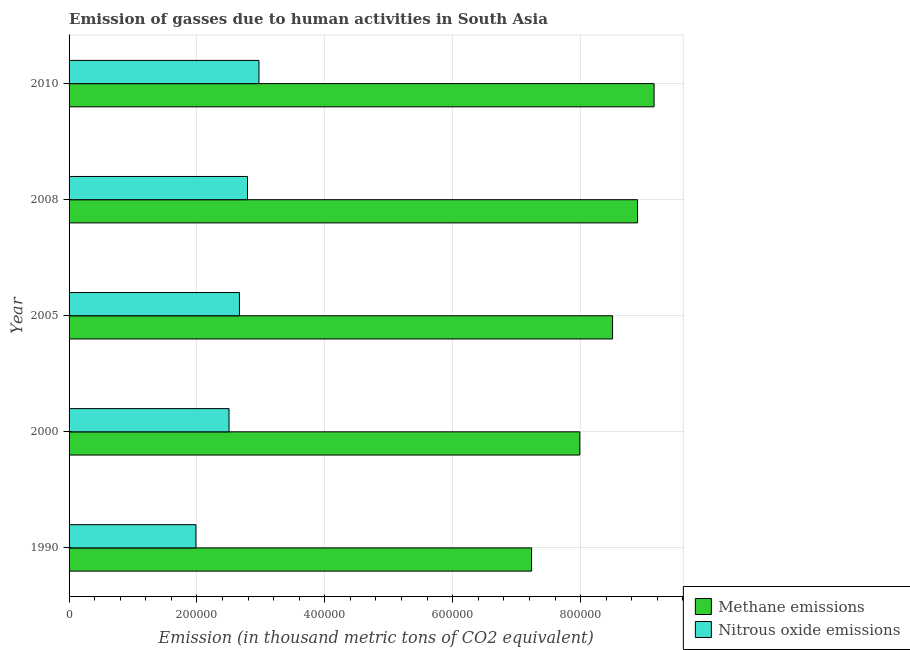How many different coloured bars are there?
Make the answer very short. 2. Are the number of bars on each tick of the Y-axis equal?
Make the answer very short. Yes. What is the amount of methane emissions in 2005?
Make the answer very short. 8.50e+05. Across all years, what is the maximum amount of methane emissions?
Make the answer very short. 9.15e+05. Across all years, what is the minimum amount of methane emissions?
Keep it short and to the point. 7.23e+05. In which year was the amount of nitrous oxide emissions maximum?
Your response must be concise. 2010. What is the total amount of nitrous oxide emissions in the graph?
Your answer should be very brief. 1.29e+06. What is the difference between the amount of methane emissions in 2008 and that in 2010?
Provide a succinct answer. -2.59e+04. What is the difference between the amount of methane emissions in 2005 and the amount of nitrous oxide emissions in 2010?
Your answer should be compact. 5.53e+05. What is the average amount of nitrous oxide emissions per year?
Your answer should be very brief. 2.58e+05. In the year 2008, what is the difference between the amount of nitrous oxide emissions and amount of methane emissions?
Ensure brevity in your answer.  -6.10e+05. In how many years, is the amount of methane emissions greater than 80000 thousand metric tons?
Your answer should be compact. 5. What is the ratio of the amount of methane emissions in 2000 to that in 2010?
Offer a very short reply. 0.87. Is the amount of methane emissions in 2005 less than that in 2008?
Offer a very short reply. Yes. Is the difference between the amount of methane emissions in 1990 and 2000 greater than the difference between the amount of nitrous oxide emissions in 1990 and 2000?
Keep it short and to the point. No. What is the difference between the highest and the second highest amount of methane emissions?
Provide a short and direct response. 2.59e+04. What is the difference between the highest and the lowest amount of methane emissions?
Provide a short and direct response. 1.92e+05. In how many years, is the amount of methane emissions greater than the average amount of methane emissions taken over all years?
Your answer should be very brief. 3. What does the 1st bar from the top in 1990 represents?
Provide a short and direct response. Nitrous oxide emissions. What does the 1st bar from the bottom in 1990 represents?
Provide a succinct answer. Methane emissions. How many bars are there?
Give a very brief answer. 10. How many years are there in the graph?
Provide a succinct answer. 5. What is the difference between two consecutive major ticks on the X-axis?
Offer a terse response. 2.00e+05. Are the values on the major ticks of X-axis written in scientific E-notation?
Keep it short and to the point. No. Where does the legend appear in the graph?
Keep it short and to the point. Bottom right. How many legend labels are there?
Provide a short and direct response. 2. What is the title of the graph?
Offer a terse response. Emission of gasses due to human activities in South Asia. What is the label or title of the X-axis?
Your response must be concise. Emission (in thousand metric tons of CO2 equivalent). What is the label or title of the Y-axis?
Your answer should be compact. Year. What is the Emission (in thousand metric tons of CO2 equivalent) in Methane emissions in 1990?
Provide a short and direct response. 7.23e+05. What is the Emission (in thousand metric tons of CO2 equivalent) in Nitrous oxide emissions in 1990?
Ensure brevity in your answer.  1.98e+05. What is the Emission (in thousand metric tons of CO2 equivalent) in Methane emissions in 2000?
Your response must be concise. 7.99e+05. What is the Emission (in thousand metric tons of CO2 equivalent) in Nitrous oxide emissions in 2000?
Offer a terse response. 2.50e+05. What is the Emission (in thousand metric tons of CO2 equivalent) in Methane emissions in 2005?
Ensure brevity in your answer.  8.50e+05. What is the Emission (in thousand metric tons of CO2 equivalent) of Nitrous oxide emissions in 2005?
Your response must be concise. 2.66e+05. What is the Emission (in thousand metric tons of CO2 equivalent) of Methane emissions in 2008?
Ensure brevity in your answer.  8.89e+05. What is the Emission (in thousand metric tons of CO2 equivalent) of Nitrous oxide emissions in 2008?
Your answer should be compact. 2.79e+05. What is the Emission (in thousand metric tons of CO2 equivalent) in Methane emissions in 2010?
Your answer should be very brief. 9.15e+05. What is the Emission (in thousand metric tons of CO2 equivalent) of Nitrous oxide emissions in 2010?
Provide a short and direct response. 2.97e+05. Across all years, what is the maximum Emission (in thousand metric tons of CO2 equivalent) in Methane emissions?
Make the answer very short. 9.15e+05. Across all years, what is the maximum Emission (in thousand metric tons of CO2 equivalent) of Nitrous oxide emissions?
Make the answer very short. 2.97e+05. Across all years, what is the minimum Emission (in thousand metric tons of CO2 equivalent) of Methane emissions?
Offer a very short reply. 7.23e+05. Across all years, what is the minimum Emission (in thousand metric tons of CO2 equivalent) in Nitrous oxide emissions?
Offer a terse response. 1.98e+05. What is the total Emission (in thousand metric tons of CO2 equivalent) of Methane emissions in the graph?
Provide a succinct answer. 4.18e+06. What is the total Emission (in thousand metric tons of CO2 equivalent) of Nitrous oxide emissions in the graph?
Give a very brief answer. 1.29e+06. What is the difference between the Emission (in thousand metric tons of CO2 equivalent) in Methane emissions in 1990 and that in 2000?
Offer a very short reply. -7.54e+04. What is the difference between the Emission (in thousand metric tons of CO2 equivalent) in Nitrous oxide emissions in 1990 and that in 2000?
Make the answer very short. -5.17e+04. What is the difference between the Emission (in thousand metric tons of CO2 equivalent) in Methane emissions in 1990 and that in 2005?
Make the answer very short. -1.27e+05. What is the difference between the Emission (in thousand metric tons of CO2 equivalent) of Nitrous oxide emissions in 1990 and that in 2005?
Offer a very short reply. -6.80e+04. What is the difference between the Emission (in thousand metric tons of CO2 equivalent) of Methane emissions in 1990 and that in 2008?
Give a very brief answer. -1.66e+05. What is the difference between the Emission (in thousand metric tons of CO2 equivalent) of Nitrous oxide emissions in 1990 and that in 2008?
Provide a succinct answer. -8.07e+04. What is the difference between the Emission (in thousand metric tons of CO2 equivalent) in Methane emissions in 1990 and that in 2010?
Your response must be concise. -1.92e+05. What is the difference between the Emission (in thousand metric tons of CO2 equivalent) of Nitrous oxide emissions in 1990 and that in 2010?
Provide a short and direct response. -9.86e+04. What is the difference between the Emission (in thousand metric tons of CO2 equivalent) of Methane emissions in 2000 and that in 2005?
Your answer should be compact. -5.12e+04. What is the difference between the Emission (in thousand metric tons of CO2 equivalent) in Nitrous oxide emissions in 2000 and that in 2005?
Give a very brief answer. -1.63e+04. What is the difference between the Emission (in thousand metric tons of CO2 equivalent) in Methane emissions in 2000 and that in 2008?
Your answer should be very brief. -9.03e+04. What is the difference between the Emission (in thousand metric tons of CO2 equivalent) of Nitrous oxide emissions in 2000 and that in 2008?
Your answer should be compact. -2.89e+04. What is the difference between the Emission (in thousand metric tons of CO2 equivalent) in Methane emissions in 2000 and that in 2010?
Keep it short and to the point. -1.16e+05. What is the difference between the Emission (in thousand metric tons of CO2 equivalent) of Nitrous oxide emissions in 2000 and that in 2010?
Offer a very short reply. -4.68e+04. What is the difference between the Emission (in thousand metric tons of CO2 equivalent) in Methane emissions in 2005 and that in 2008?
Provide a short and direct response. -3.91e+04. What is the difference between the Emission (in thousand metric tons of CO2 equivalent) of Nitrous oxide emissions in 2005 and that in 2008?
Your answer should be very brief. -1.26e+04. What is the difference between the Emission (in thousand metric tons of CO2 equivalent) of Methane emissions in 2005 and that in 2010?
Give a very brief answer. -6.50e+04. What is the difference between the Emission (in thousand metric tons of CO2 equivalent) of Nitrous oxide emissions in 2005 and that in 2010?
Your response must be concise. -3.06e+04. What is the difference between the Emission (in thousand metric tons of CO2 equivalent) in Methane emissions in 2008 and that in 2010?
Offer a very short reply. -2.59e+04. What is the difference between the Emission (in thousand metric tons of CO2 equivalent) in Nitrous oxide emissions in 2008 and that in 2010?
Your answer should be very brief. -1.79e+04. What is the difference between the Emission (in thousand metric tons of CO2 equivalent) in Methane emissions in 1990 and the Emission (in thousand metric tons of CO2 equivalent) in Nitrous oxide emissions in 2000?
Your answer should be very brief. 4.73e+05. What is the difference between the Emission (in thousand metric tons of CO2 equivalent) in Methane emissions in 1990 and the Emission (in thousand metric tons of CO2 equivalent) in Nitrous oxide emissions in 2005?
Keep it short and to the point. 4.57e+05. What is the difference between the Emission (in thousand metric tons of CO2 equivalent) of Methane emissions in 1990 and the Emission (in thousand metric tons of CO2 equivalent) of Nitrous oxide emissions in 2008?
Your answer should be compact. 4.44e+05. What is the difference between the Emission (in thousand metric tons of CO2 equivalent) of Methane emissions in 1990 and the Emission (in thousand metric tons of CO2 equivalent) of Nitrous oxide emissions in 2010?
Give a very brief answer. 4.26e+05. What is the difference between the Emission (in thousand metric tons of CO2 equivalent) of Methane emissions in 2000 and the Emission (in thousand metric tons of CO2 equivalent) of Nitrous oxide emissions in 2005?
Offer a terse response. 5.32e+05. What is the difference between the Emission (in thousand metric tons of CO2 equivalent) of Methane emissions in 2000 and the Emission (in thousand metric tons of CO2 equivalent) of Nitrous oxide emissions in 2008?
Your answer should be very brief. 5.20e+05. What is the difference between the Emission (in thousand metric tons of CO2 equivalent) in Methane emissions in 2000 and the Emission (in thousand metric tons of CO2 equivalent) in Nitrous oxide emissions in 2010?
Ensure brevity in your answer.  5.02e+05. What is the difference between the Emission (in thousand metric tons of CO2 equivalent) of Methane emissions in 2005 and the Emission (in thousand metric tons of CO2 equivalent) of Nitrous oxide emissions in 2008?
Provide a succinct answer. 5.71e+05. What is the difference between the Emission (in thousand metric tons of CO2 equivalent) in Methane emissions in 2005 and the Emission (in thousand metric tons of CO2 equivalent) in Nitrous oxide emissions in 2010?
Give a very brief answer. 5.53e+05. What is the difference between the Emission (in thousand metric tons of CO2 equivalent) in Methane emissions in 2008 and the Emission (in thousand metric tons of CO2 equivalent) in Nitrous oxide emissions in 2010?
Keep it short and to the point. 5.92e+05. What is the average Emission (in thousand metric tons of CO2 equivalent) of Methane emissions per year?
Provide a short and direct response. 8.35e+05. What is the average Emission (in thousand metric tons of CO2 equivalent) in Nitrous oxide emissions per year?
Ensure brevity in your answer.  2.58e+05. In the year 1990, what is the difference between the Emission (in thousand metric tons of CO2 equivalent) of Methane emissions and Emission (in thousand metric tons of CO2 equivalent) of Nitrous oxide emissions?
Offer a terse response. 5.25e+05. In the year 2000, what is the difference between the Emission (in thousand metric tons of CO2 equivalent) in Methane emissions and Emission (in thousand metric tons of CO2 equivalent) in Nitrous oxide emissions?
Your response must be concise. 5.49e+05. In the year 2005, what is the difference between the Emission (in thousand metric tons of CO2 equivalent) of Methane emissions and Emission (in thousand metric tons of CO2 equivalent) of Nitrous oxide emissions?
Make the answer very short. 5.84e+05. In the year 2008, what is the difference between the Emission (in thousand metric tons of CO2 equivalent) in Methane emissions and Emission (in thousand metric tons of CO2 equivalent) in Nitrous oxide emissions?
Give a very brief answer. 6.10e+05. In the year 2010, what is the difference between the Emission (in thousand metric tons of CO2 equivalent) in Methane emissions and Emission (in thousand metric tons of CO2 equivalent) in Nitrous oxide emissions?
Provide a short and direct response. 6.18e+05. What is the ratio of the Emission (in thousand metric tons of CO2 equivalent) of Methane emissions in 1990 to that in 2000?
Ensure brevity in your answer.  0.91. What is the ratio of the Emission (in thousand metric tons of CO2 equivalent) of Nitrous oxide emissions in 1990 to that in 2000?
Keep it short and to the point. 0.79. What is the ratio of the Emission (in thousand metric tons of CO2 equivalent) of Methane emissions in 1990 to that in 2005?
Keep it short and to the point. 0.85. What is the ratio of the Emission (in thousand metric tons of CO2 equivalent) in Nitrous oxide emissions in 1990 to that in 2005?
Your answer should be compact. 0.74. What is the ratio of the Emission (in thousand metric tons of CO2 equivalent) of Methane emissions in 1990 to that in 2008?
Your response must be concise. 0.81. What is the ratio of the Emission (in thousand metric tons of CO2 equivalent) of Nitrous oxide emissions in 1990 to that in 2008?
Make the answer very short. 0.71. What is the ratio of the Emission (in thousand metric tons of CO2 equivalent) in Methane emissions in 1990 to that in 2010?
Your response must be concise. 0.79. What is the ratio of the Emission (in thousand metric tons of CO2 equivalent) of Nitrous oxide emissions in 1990 to that in 2010?
Provide a short and direct response. 0.67. What is the ratio of the Emission (in thousand metric tons of CO2 equivalent) of Methane emissions in 2000 to that in 2005?
Ensure brevity in your answer.  0.94. What is the ratio of the Emission (in thousand metric tons of CO2 equivalent) of Nitrous oxide emissions in 2000 to that in 2005?
Provide a short and direct response. 0.94. What is the ratio of the Emission (in thousand metric tons of CO2 equivalent) in Methane emissions in 2000 to that in 2008?
Your answer should be compact. 0.9. What is the ratio of the Emission (in thousand metric tons of CO2 equivalent) in Nitrous oxide emissions in 2000 to that in 2008?
Offer a terse response. 0.9. What is the ratio of the Emission (in thousand metric tons of CO2 equivalent) of Methane emissions in 2000 to that in 2010?
Your response must be concise. 0.87. What is the ratio of the Emission (in thousand metric tons of CO2 equivalent) in Nitrous oxide emissions in 2000 to that in 2010?
Provide a succinct answer. 0.84. What is the ratio of the Emission (in thousand metric tons of CO2 equivalent) in Methane emissions in 2005 to that in 2008?
Provide a short and direct response. 0.96. What is the ratio of the Emission (in thousand metric tons of CO2 equivalent) in Nitrous oxide emissions in 2005 to that in 2008?
Offer a very short reply. 0.95. What is the ratio of the Emission (in thousand metric tons of CO2 equivalent) of Methane emissions in 2005 to that in 2010?
Offer a very short reply. 0.93. What is the ratio of the Emission (in thousand metric tons of CO2 equivalent) in Nitrous oxide emissions in 2005 to that in 2010?
Provide a succinct answer. 0.9. What is the ratio of the Emission (in thousand metric tons of CO2 equivalent) of Methane emissions in 2008 to that in 2010?
Make the answer very short. 0.97. What is the ratio of the Emission (in thousand metric tons of CO2 equivalent) of Nitrous oxide emissions in 2008 to that in 2010?
Provide a succinct answer. 0.94. What is the difference between the highest and the second highest Emission (in thousand metric tons of CO2 equivalent) of Methane emissions?
Your response must be concise. 2.59e+04. What is the difference between the highest and the second highest Emission (in thousand metric tons of CO2 equivalent) in Nitrous oxide emissions?
Provide a succinct answer. 1.79e+04. What is the difference between the highest and the lowest Emission (in thousand metric tons of CO2 equivalent) of Methane emissions?
Make the answer very short. 1.92e+05. What is the difference between the highest and the lowest Emission (in thousand metric tons of CO2 equivalent) of Nitrous oxide emissions?
Offer a very short reply. 9.86e+04. 